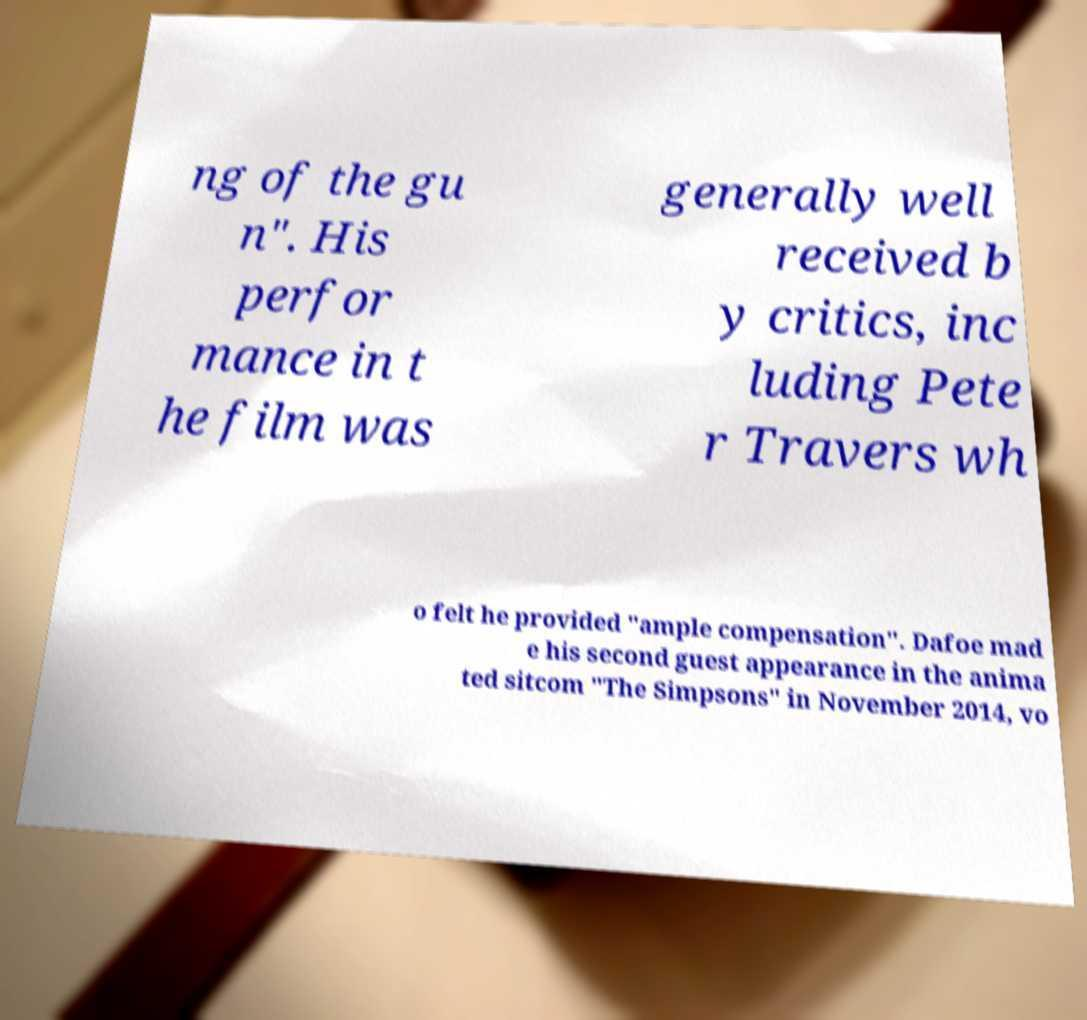Please identify and transcribe the text found in this image. ng of the gu n". His perfor mance in t he film was generally well received b y critics, inc luding Pete r Travers wh o felt he provided "ample compensation". Dafoe mad e his second guest appearance in the anima ted sitcom "The Simpsons" in November 2014, vo 